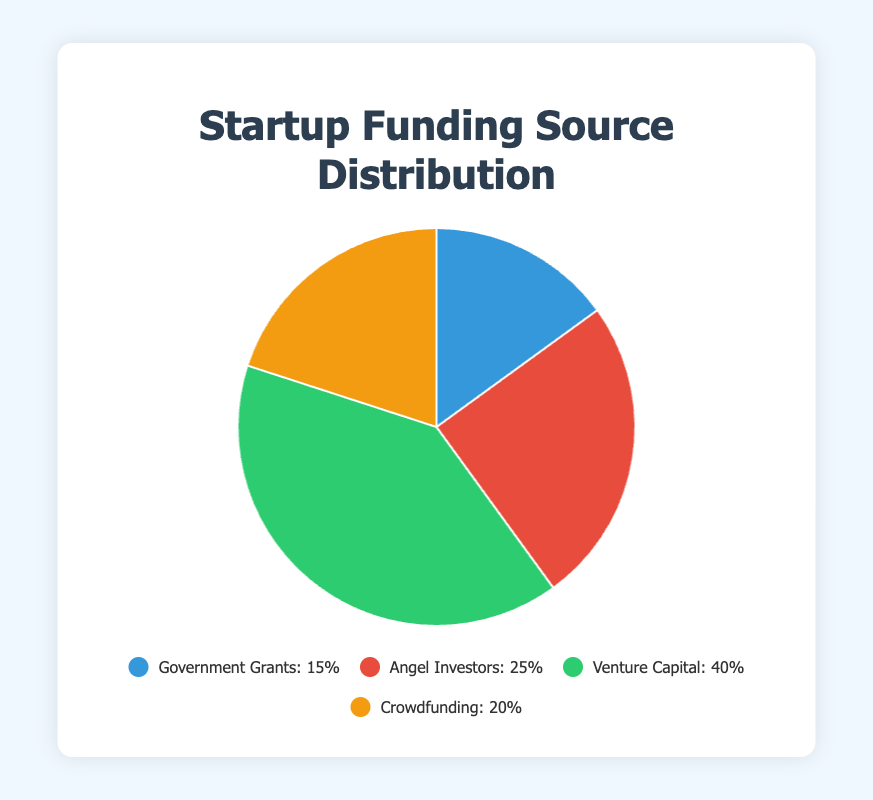What is the largest funding source shown in the chart? The largest funding source is identified by the largest segment in the pie chart, labeled "Venture Capital" with 40%.
Answer: Venture Capital What is the total percentage of funding from non-investors (Government Grants and Crowdfunding)? Add the percentages of Government Grants (15%) and Crowdfunding (20%). 15 + 20 = 35
Answer: 35% Which funding source has a higher percentage, Angel Investors or Crowdfunding? Compare the percentages for Angel Investors (25%) and Crowdfunding (20%). Angel Investors have a higher percentage.
Answer: Angel Investors What is the difference in the percentage between Angel Investors and Government Grants? Subtract the percentage for Government Grants (15%) from the percentage for Angel Investors (25%). 25 - 15 = 10
Answer: 10% Which funding source occupies the smallest segment on the pie chart, and what is its percentage? The smallest segment is labeled "Government Grants" with 15%.
Answer: Government Grants, 15% If we combine the percentage of Angel Investors and Crowdfunding, does it exceed the percentage of Venture Capital? Add percentages of Angel Investors (25%) and Crowdfunding (20%) to get 45%. Compare it with Venture Capital (40%). 45% is greater than 40%.
Answer: Yes Is the percentage of Crowdfunding larger than 15%? Compare the percentage for Crowdfunding (20%) with 15%. 20% is larger.
Answer: Yes What portion of the chart is represented by the green color? The green segment corresponds to "Venture Capital" which represents 40% of the chart.
Answer: 40% Are the percentages of Crowdfunding and Government Grants combined less than 50%? Add the percentages for Crowdfunding (20%) and Government Grants (15%). 20 + 15 = 35, which is less than 50.
Answer: Yes 